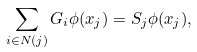Convert formula to latex. <formula><loc_0><loc_0><loc_500><loc_500>\sum _ { i \in N ( j ) } G _ { i } \phi ( x _ { j } ) & = S _ { j } \phi ( x _ { j } ) ,</formula> 